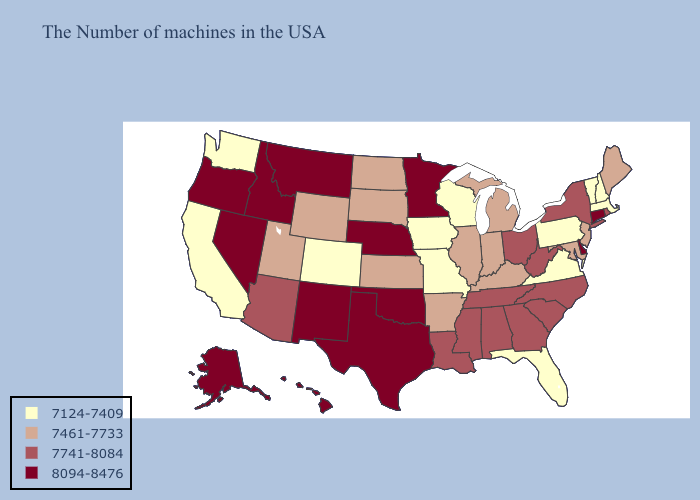Name the states that have a value in the range 7741-8084?
Concise answer only. Rhode Island, New York, North Carolina, South Carolina, West Virginia, Ohio, Georgia, Alabama, Tennessee, Mississippi, Louisiana, Arizona. Does Rhode Island have the lowest value in the Northeast?
Give a very brief answer. No. Which states hav the highest value in the Northeast?
Keep it brief. Connecticut. Among the states that border Nevada , does Idaho have the highest value?
Answer briefly. Yes. Which states have the lowest value in the Northeast?
Keep it brief. Massachusetts, New Hampshire, Vermont, Pennsylvania. What is the lowest value in states that border Pennsylvania?
Quick response, please. 7461-7733. What is the value of Rhode Island?
Concise answer only. 7741-8084. Among the states that border Kentucky , which have the lowest value?
Give a very brief answer. Virginia, Missouri. Name the states that have a value in the range 7124-7409?
Keep it brief. Massachusetts, New Hampshire, Vermont, Pennsylvania, Virginia, Florida, Wisconsin, Missouri, Iowa, Colorado, California, Washington. Does Missouri have the lowest value in the USA?
Be succinct. Yes. Name the states that have a value in the range 7461-7733?
Concise answer only. Maine, New Jersey, Maryland, Michigan, Kentucky, Indiana, Illinois, Arkansas, Kansas, South Dakota, North Dakota, Wyoming, Utah. Name the states that have a value in the range 7461-7733?
Give a very brief answer. Maine, New Jersey, Maryland, Michigan, Kentucky, Indiana, Illinois, Arkansas, Kansas, South Dakota, North Dakota, Wyoming, Utah. What is the value of Illinois?
Be succinct. 7461-7733. Among the states that border Wyoming , which have the lowest value?
Be succinct. Colorado. Which states have the lowest value in the South?
Be succinct. Virginia, Florida. 